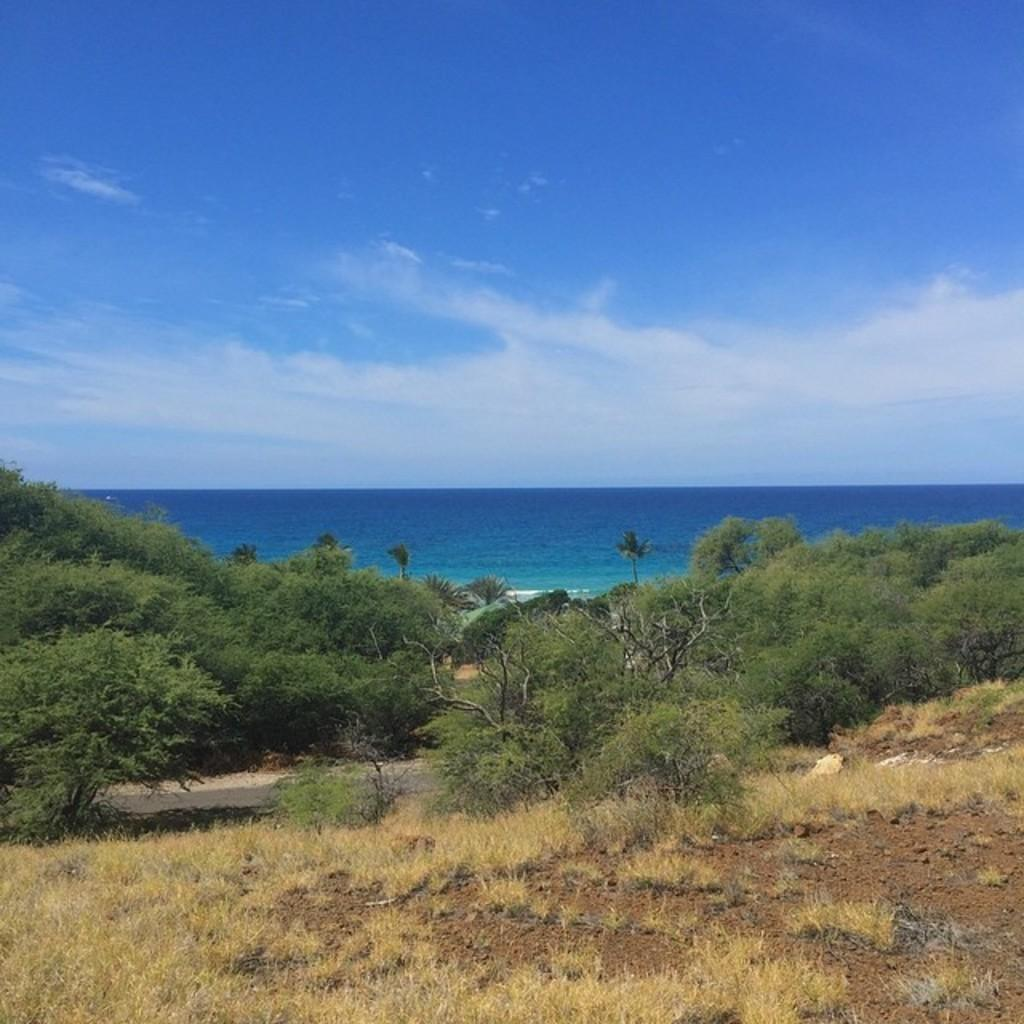What type of vegetation can be seen in the image? There is grass in the image. Are there any other plants visible in the image? Yes, there are trees in the image. What can be seen besides the vegetation in the image? Water is visible in the image. What is visible in the background of the image? The sky is visible in the background of the image. What type of skin condition can be seen on the trees in the image? There is no mention of any skin condition on the trees in the image. The trees appear to be healthy and normal. 